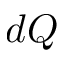<formula> <loc_0><loc_0><loc_500><loc_500>d Q</formula> 